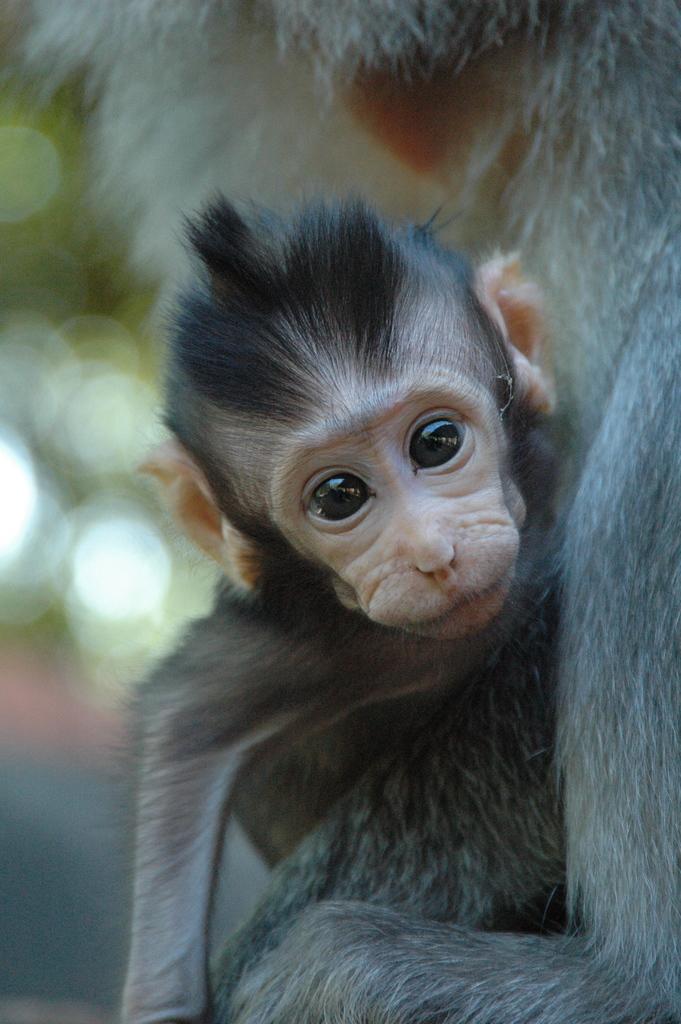Can you describe this image briefly? As we can see in the image there is a monkey and the background is blurred. 